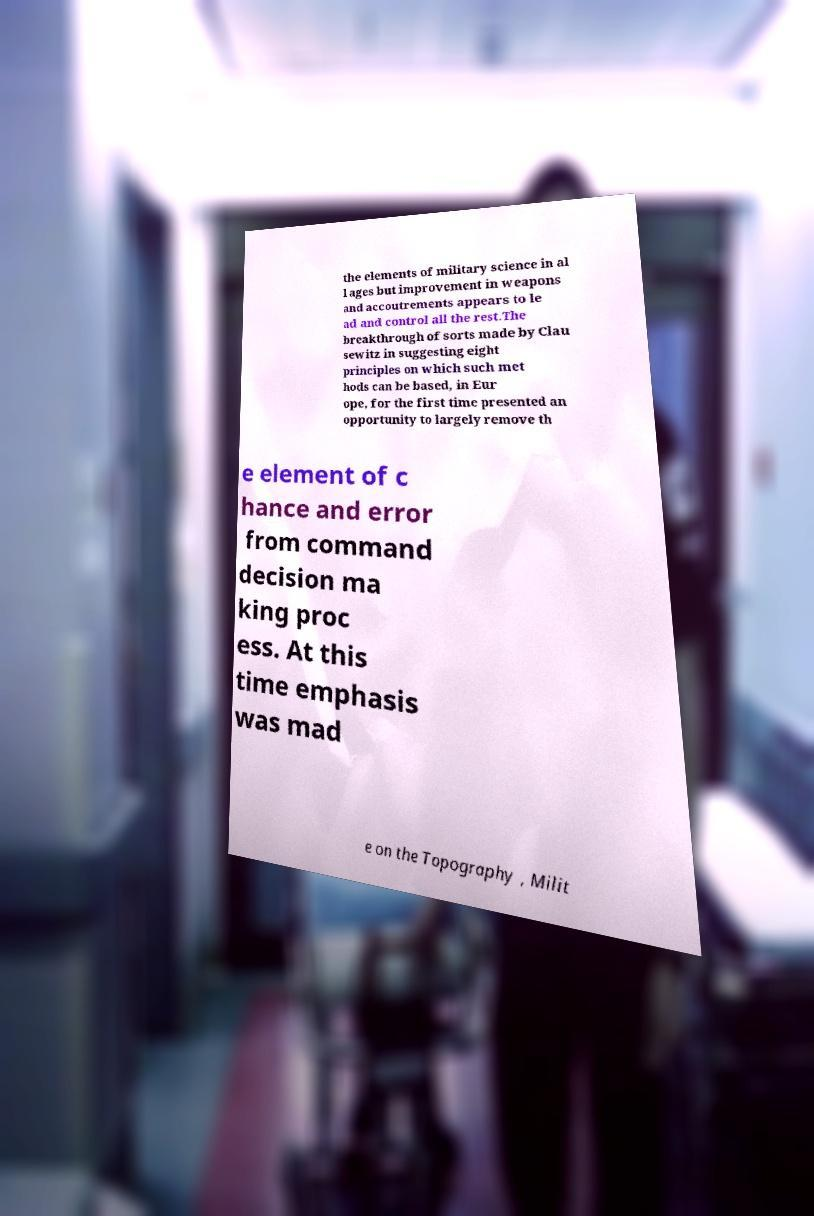Please read and relay the text visible in this image. What does it say? the elements of military science in al l ages but improvement in weapons and accoutrements appears to le ad and control all the rest.The breakthrough of sorts made by Clau sewitz in suggesting eight principles on which such met hods can be based, in Eur ope, for the first time presented an opportunity to largely remove th e element of c hance and error from command decision ma king proc ess. At this time emphasis was mad e on the Topography , Milit 